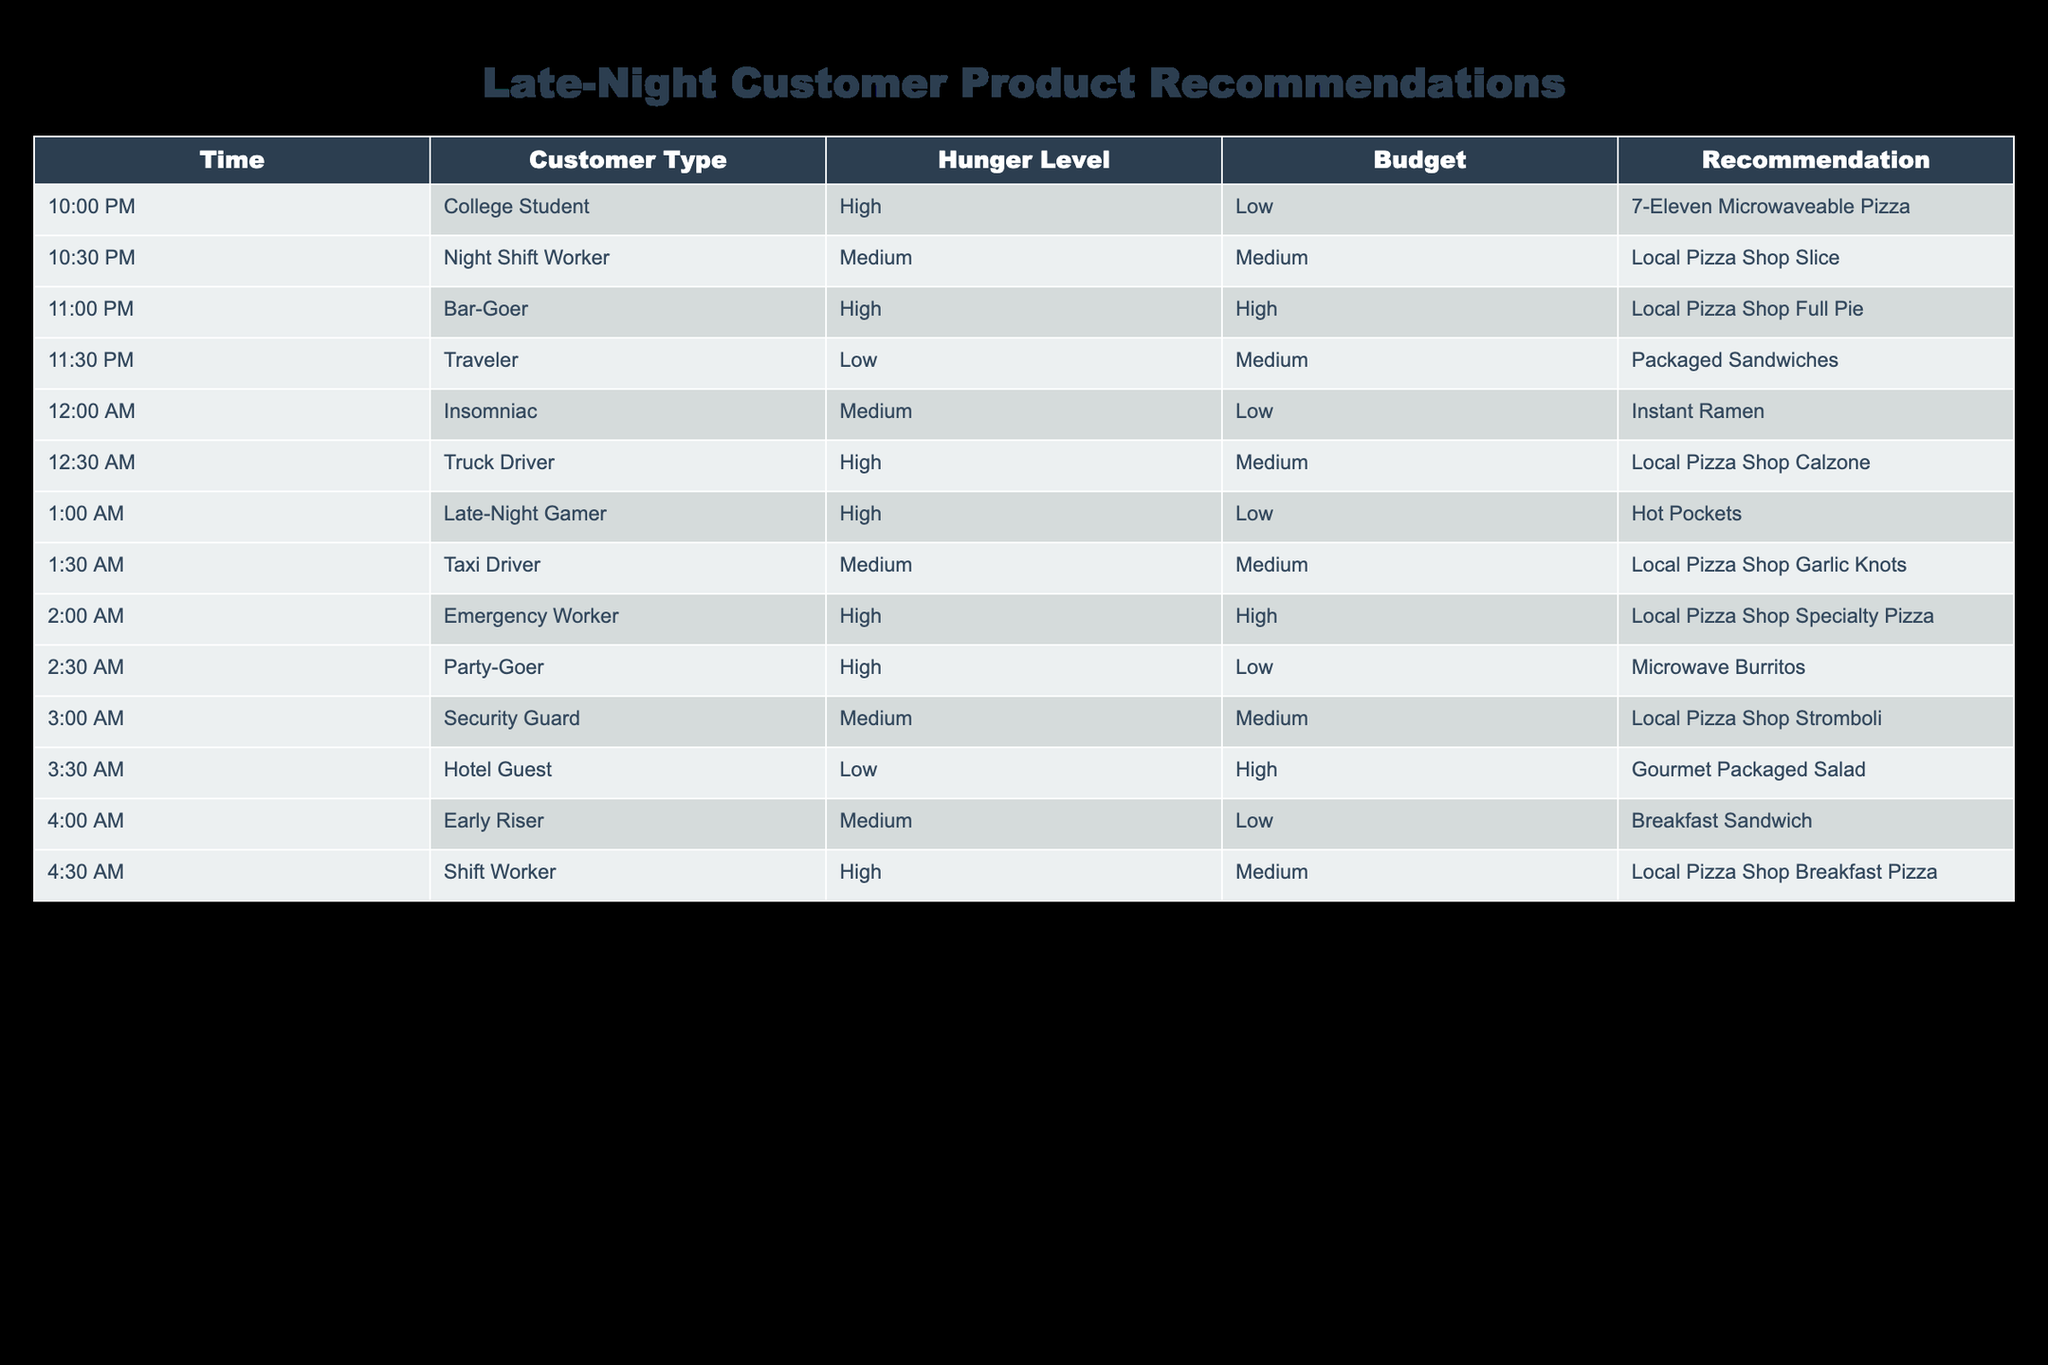What recommendation is made for a college student at 10:00 PM? The table shows that for a college student who has high hunger and low budget at 10:00 PM, the recommendation is "7-Eleven Microwaveable Pizza".
Answer: 7-Eleven Microwaveable Pizza How many recommendations are there for customers with a high hunger level? By reviewing the table, I count the rows where the hunger level is high: there are 6 entries (College Student, Bar-Goer, Truck Driver, Emergency Worker, Party-Goer, and Shift Worker).
Answer: 6 Is a packaged sandwich recommended for any customer at midnight? Checking the data from the table, at 12:00 AM, a traveler with a low hunger level and medium budget is recommended to have a packaged sandwich. Therefore, the answer is yes.
Answer: Yes Which customer type has the highest budget recommendation at 3:30 AM? Looking at the table, I see the hotel guest at 3:30 AM has a high budget, recommended to eat a gourmet packaged salad. No other higher budget entries are present for that time.
Answer: Hotel Guest What is the recommendation for the customer type that has a medium hunger level and low budget? I look for entries where the hunger level is medium and the budget is low; the only match is for the early riser at 4:00 AM, recommended to have a breakfast sandwich.
Answer: Breakfast Sandwich How many customers are recommended to visit the local pizza shop? I need to find all rows where the recommendation includes "Local Pizza Shop." From the table, it appears 5 customers have this recommendation (Night Shift Worker, Bar-Goer, Truck Driver, Taxi Driver, Emergency Worker, and Shift Worker).
Answer: 5 